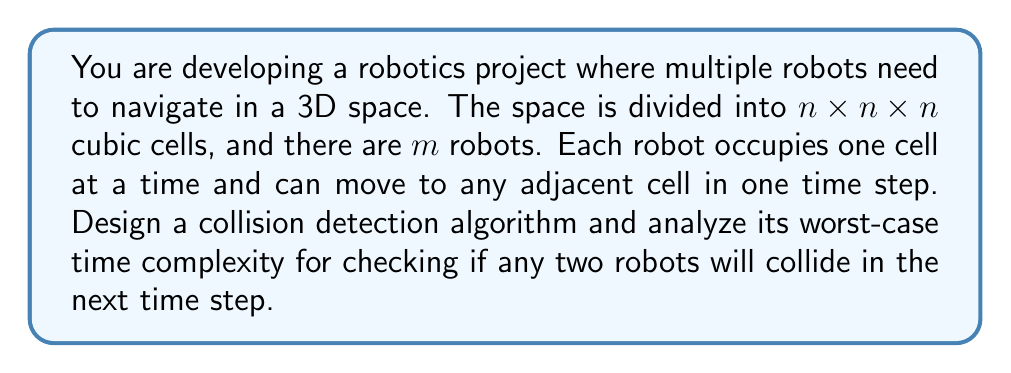Can you answer this question? To solve this problem, we need to design an algorithm and then analyze its worst-case time complexity. Let's break it down step by step:

1. Algorithm Design:
   - For each robot, we need to check its current position and all possible next positions (up to 6 adjacent cells in 3D space).
   - We need to compare these positions with all other robots' current and possible next positions.

2. Worst-case Scenario:
   - The worst case occurs when we need to check every robot against every other robot.

3. Time Complexity Analysis:
   - For each robot, we check up to 7 positions (current + 6 adjacent).
   - We need to compare each robot with every other robot.
   - This results in a nested loop structure.

4. Mathematical Formulation:
   - Outer loop: Iterates through all $m$ robots
   - Inner loop: For each robot, compares with all other $(m-1)$ robots
   - For each comparison, we check up to $7 \times 7 = 49$ position combinations

5. Calculating Complexity:
   - Total number of comparisons: $\frac{m(m-1)}{2}$ (as we don't need to check a robot against itself or repeat comparisons)
   - For each comparison, we perform up to 49 position checks
   - Resulting in: $49 \times \frac{m(m-1)}{2}$ operations

6. Simplifying:
   - This simplifies to $O(m^2)$ in Big O notation, as we drop constants and lower-order terms.

Therefore, the worst-case time complexity of this collision detection algorithm is $O(m^2)$, where $m$ is the number of robots.
Answer: The worst-case time complexity of the collision detection algorithm is $O(m^2)$, where $m$ is the number of robots. 